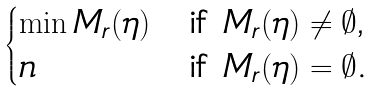Convert formula to latex. <formula><loc_0><loc_0><loc_500><loc_500>\begin{cases} \min M _ { r } ( \eta ) & \text {if $M_{r}(\eta)\ne\emptyset$,} \\ n & \text {if $M_{r}(\eta)=\emptyset$.} \end{cases}</formula> 